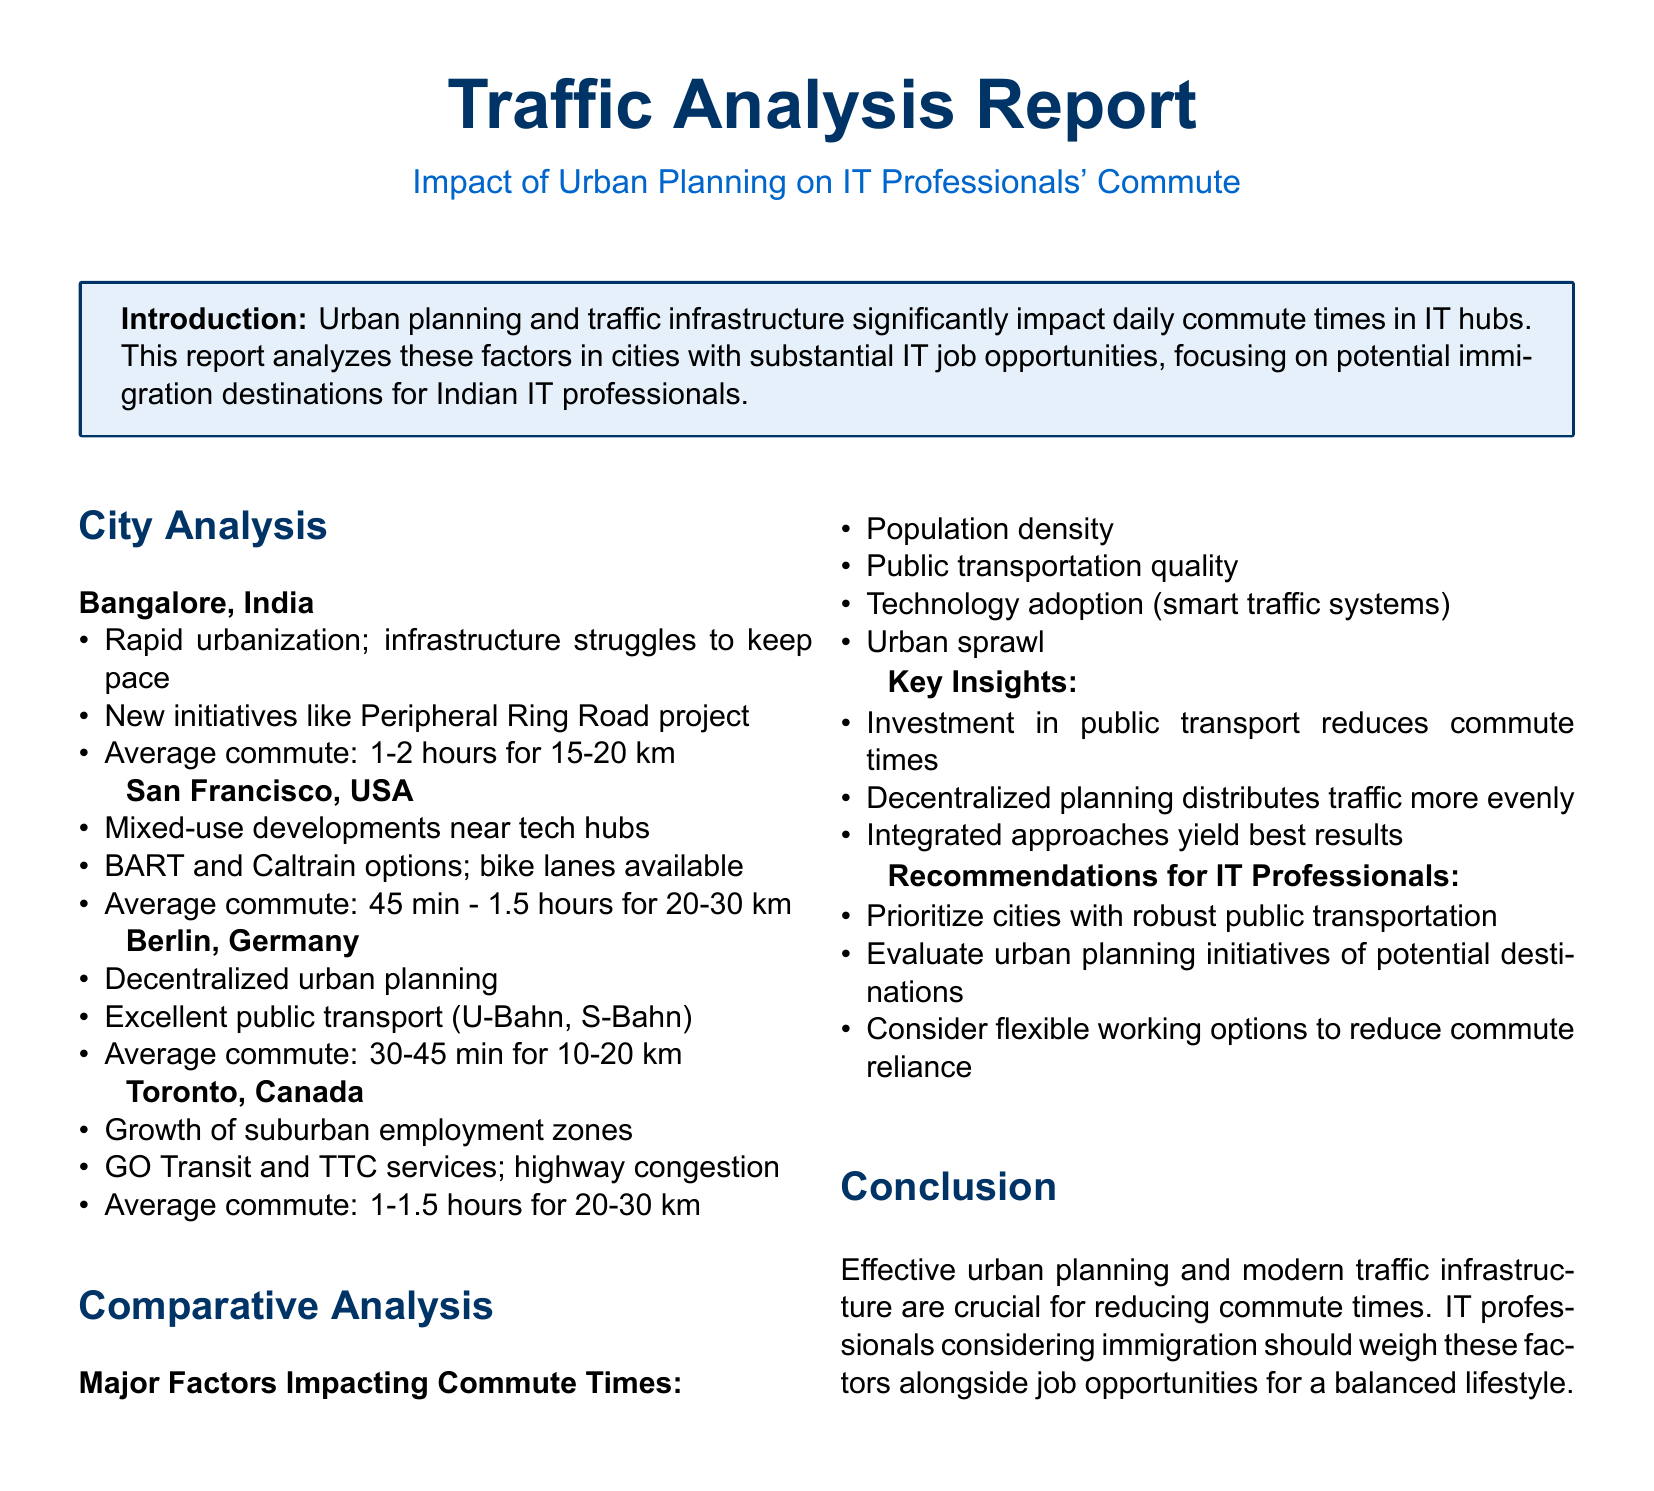what is the average commute time in Bangalore? The average commute time in Bangalore is mentioned in the report as 1-2 hours for 15-20 km.
Answer: 1-2 hours what is a notable transportation option in San Francisco? The report states that BART and Caltrain are notable transportation options in San Francisco.
Answer: BART and Caltrain how does the average commute time in Berlin compare to Toronto? The average commute time in Berlin (30-45 min) is shorter than in Toronto (1-1.5 hours).
Answer: Shorter what factor is highlighted for reducing commute times? The report highlights that investment in public transport reduces commute times.
Answer: Investment in public transport which city has decentralized urban planning? The document states that Berlin has decentralized urban planning.
Answer: Berlin what is a key insight regarding urban planning? A key insight is that decentralized planning distributes traffic more evenly.
Answer: Decentralized planning what should IT professionals prioritize when considering immigration? The report recommends that IT professionals prioritize cities with robust public transportation.
Answer: Cities with robust public transportation which country is associated with the city of Toronto? The city of Toronto is associated with Canada as mentioned in the document.
Answer: Canada how long is the average commute in San Francisco for 20-30 km? The average commute in San Francisco for 20-30 km is 45 min - 1.5 hours.
Answer: 45 min - 1.5 hours 